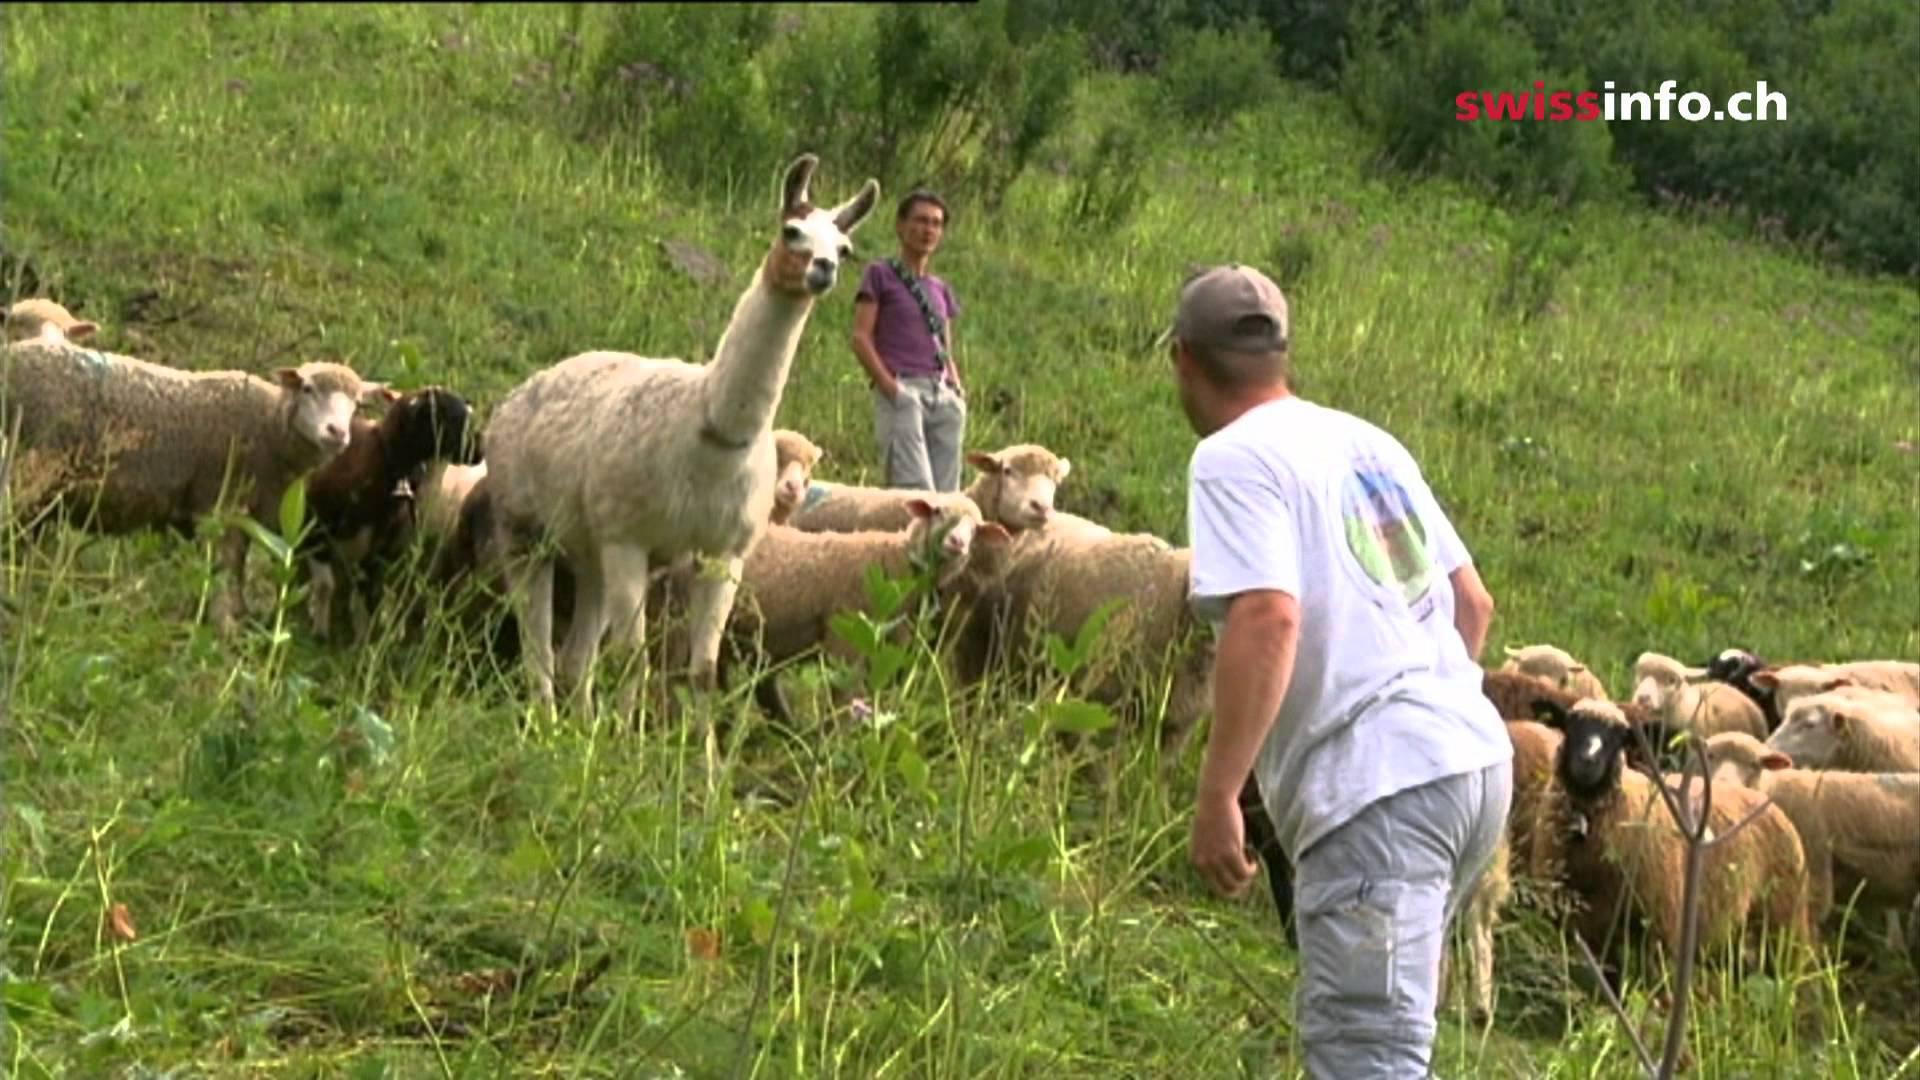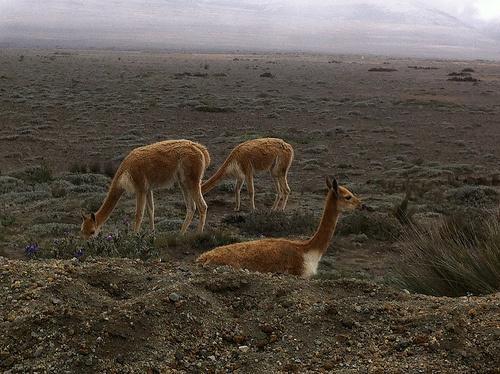The first image is the image on the left, the second image is the image on the right. For the images shown, is this caption "There are no more than two llamas." true? Answer yes or no. No. The first image is the image on the left, the second image is the image on the right. Considering the images on both sides, is "The llama in the foreground of the left image is standing with its body and head turned leftward, and the right image includes one young-looking llama with long legs who is standing in profile." valid? Answer yes or no. No. 